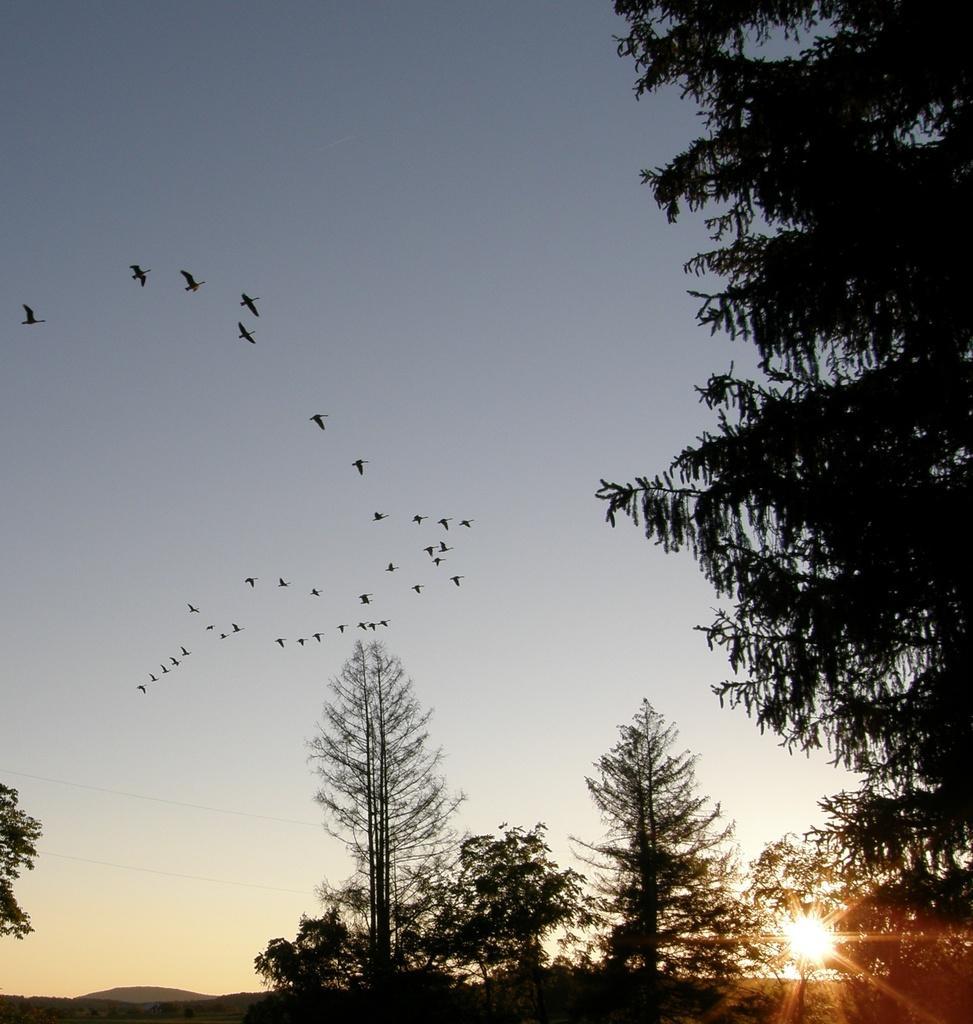How would you summarize this image in a sentence or two? In this image we can see trees, flocks of birds and sky. 